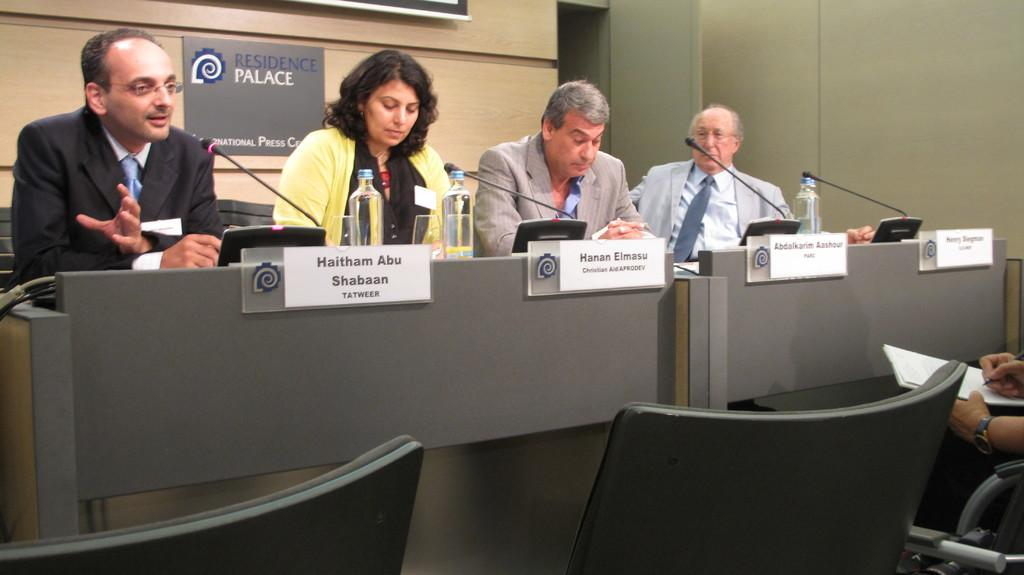What are the persons in the image doing? The persons in the image are sitting on chairs. What other objects can be seen in the image? There are mice, bottles, and posters in the image. What is the background of the image? There is a wall in the image. What is the person sitting on the right side holding? The person sitting on the right side is holding a book. What type of feather can be seen on the person sitting on the left side in the image? There is no feather visible on the person sitting on the left side in the image. What type of wool is used to make the mice in the image? The image does not provide information about the materials used to make the mice, so it cannot be determined from the image. 